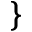<formula> <loc_0><loc_0><loc_500><loc_500>\}</formula> 